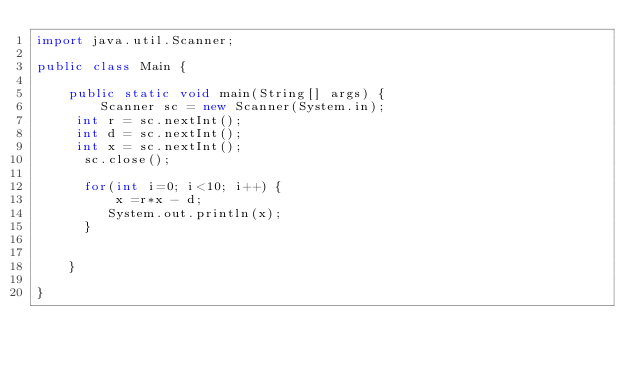<code> <loc_0><loc_0><loc_500><loc_500><_Java_>import java.util.Scanner;

public class Main {

	public static void main(String[] args) {
		Scanner sc = new Scanner(System.in);
     int r = sc.nextInt();
     int d = sc.nextInt();
     int x = sc.nextInt();
	  sc.close();
	  
	  for(int i=0; i<10; i++) {
		  x =r*x - d;
		 System.out.println(x);
	  }
	
	
	}

}
</code> 